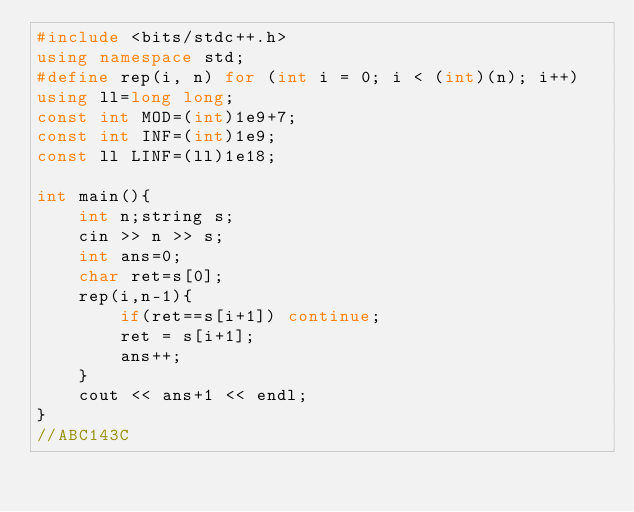<code> <loc_0><loc_0><loc_500><loc_500><_C++_>#include <bits/stdc++.h>
using namespace std;
#define rep(i, n) for (int i = 0; i < (int)(n); i++)
using ll=long long;
const int MOD=(int)1e9+7;
const int INF=(int)1e9;
const ll LINF=(ll)1e18;

int main(){
    int n;string s;
    cin >> n >> s;
    int ans=0;
    char ret=s[0];
    rep(i,n-1){
        if(ret==s[i+1]) continue;
        ret = s[i+1];
        ans++;
    }
    cout << ans+1 << endl;
}
//ABC143C</code> 